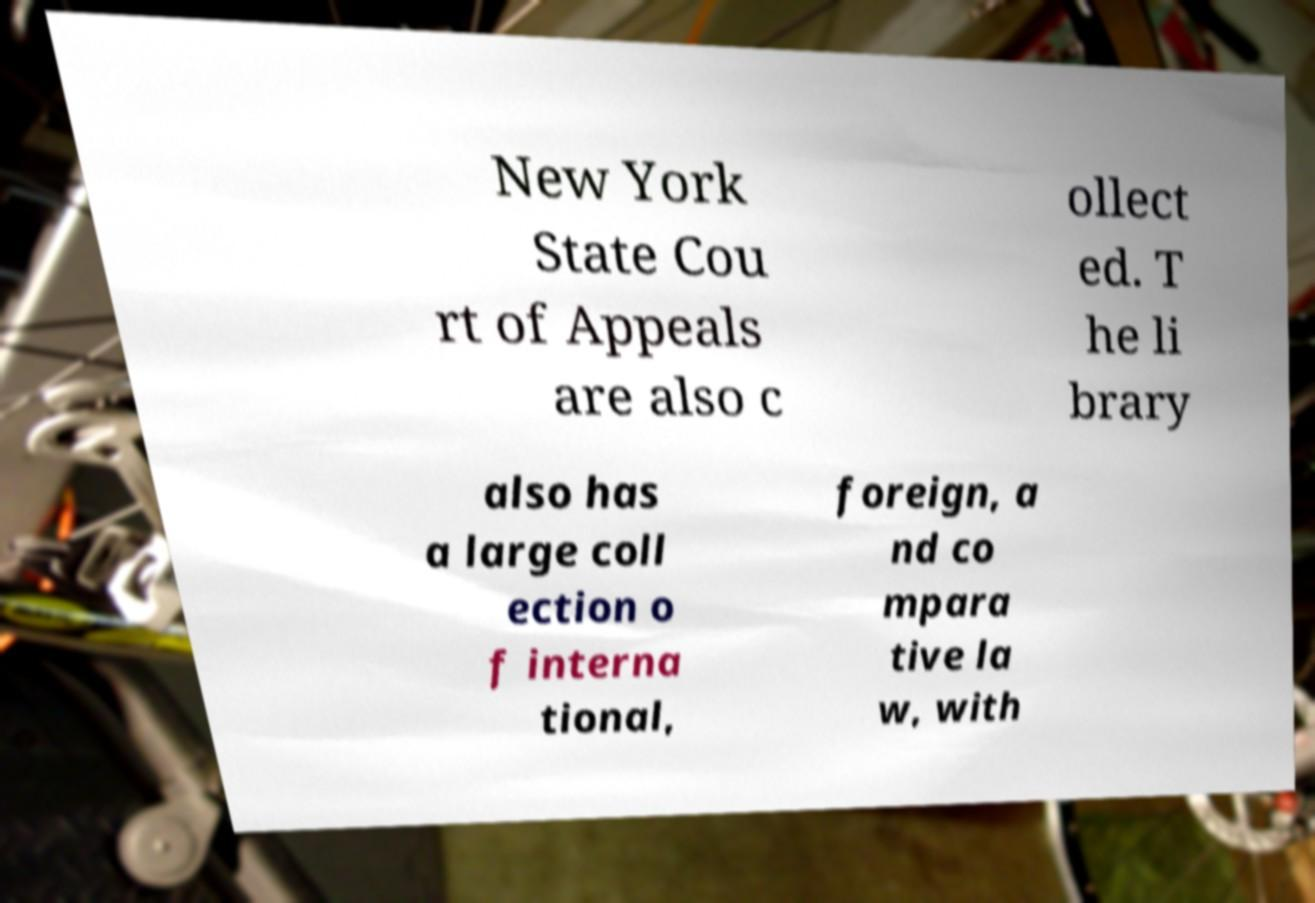I need the written content from this picture converted into text. Can you do that? New York State Cou rt of Appeals are also c ollect ed. T he li brary also has a large coll ection o f interna tional, foreign, a nd co mpara tive la w, with 